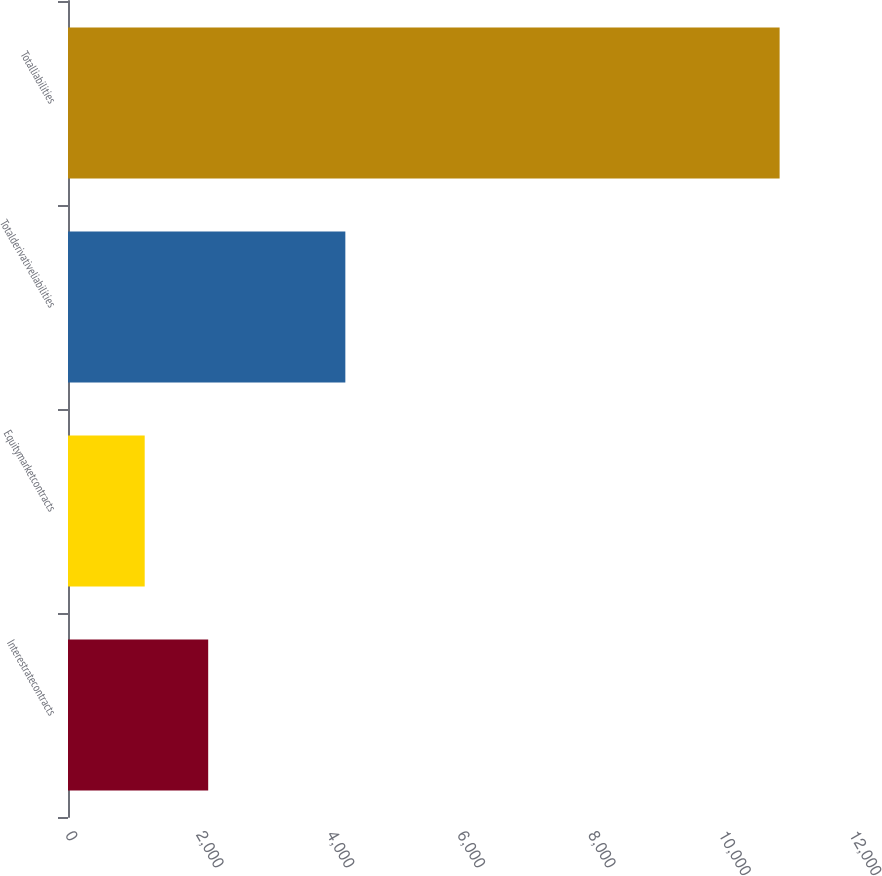<chart> <loc_0><loc_0><loc_500><loc_500><bar_chart><fcel>Interestratecontracts<fcel>Equitymarketcontracts<fcel>Totalderivativeliabilities<fcel>Totalliabilities<nl><fcel>2145.8<fcel>1174<fcel>4245<fcel>10892<nl></chart> 